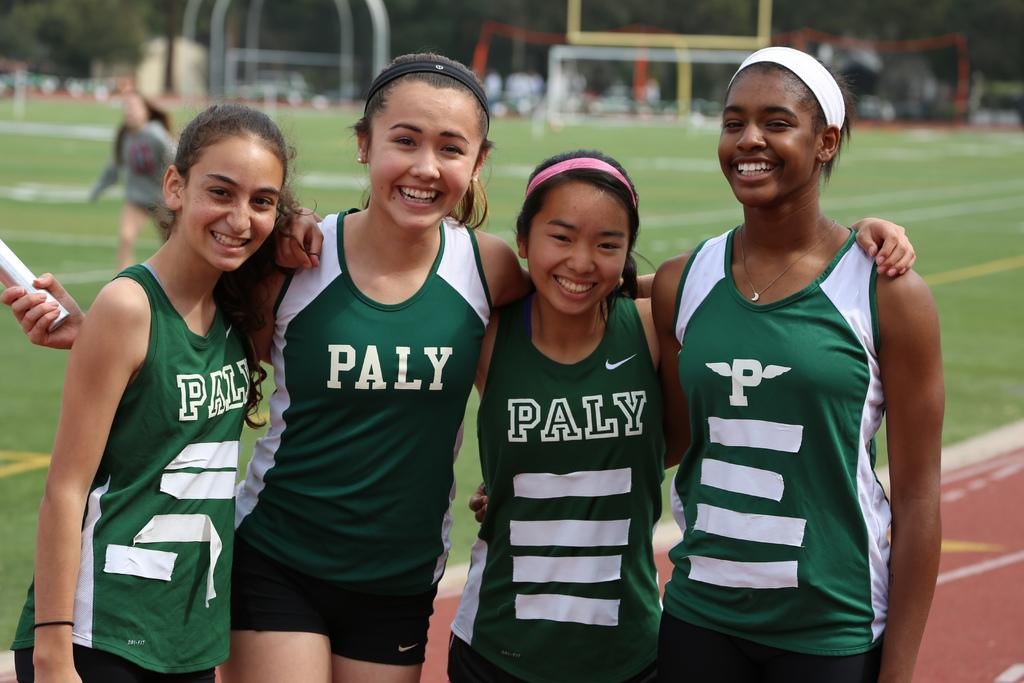<image>
Write a terse but informative summary of the picture. Four teen athletes wearing Paly uniforms on a field. 